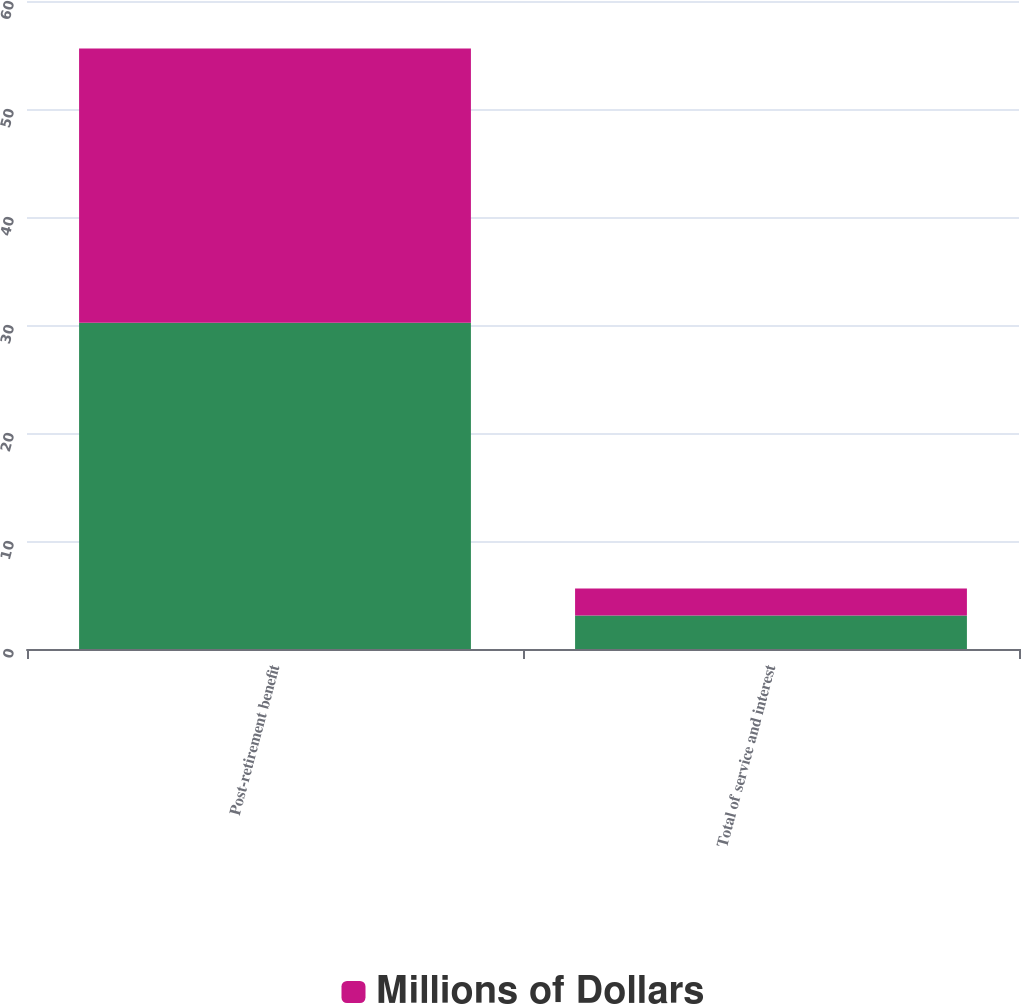Convert chart to OTSL. <chart><loc_0><loc_0><loc_500><loc_500><stacked_bar_chart><ecel><fcel>Post-retirement benefit<fcel>Total of service and interest<nl><fcel>nan<fcel>30.2<fcel>3.1<nl><fcel>Millions of Dollars<fcel>25.4<fcel>2.5<nl></chart> 